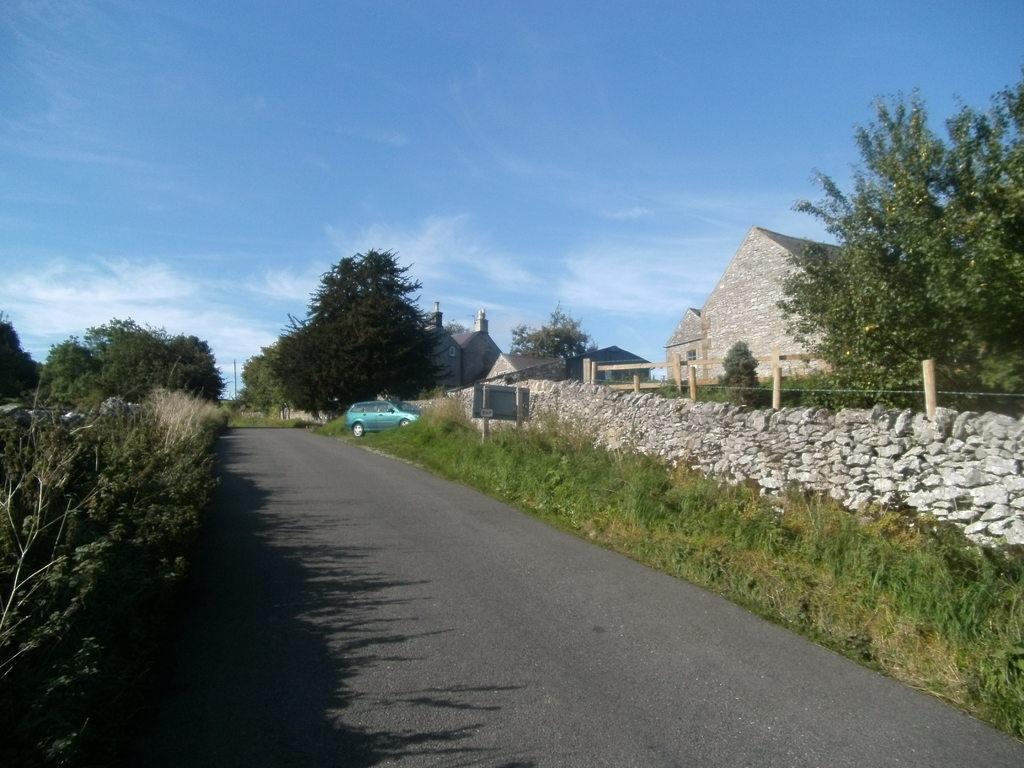How would you summarize this image in a sentence or two? In this image we can see the road and there is a car and we can see some plants, trees and grass on the ground. There are some buildings on the right side of the image and there is a compound wall and at the top we can see the sky. 